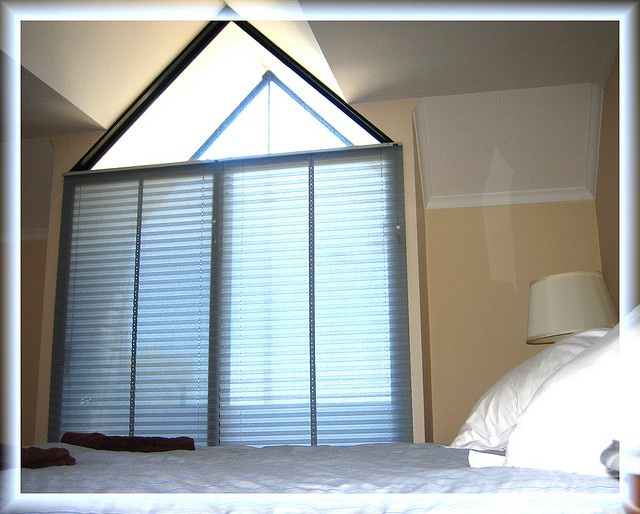Describe the objects in this image and their specific colors. I can see a bed in gray, white, darkgray, and black tones in this image. 